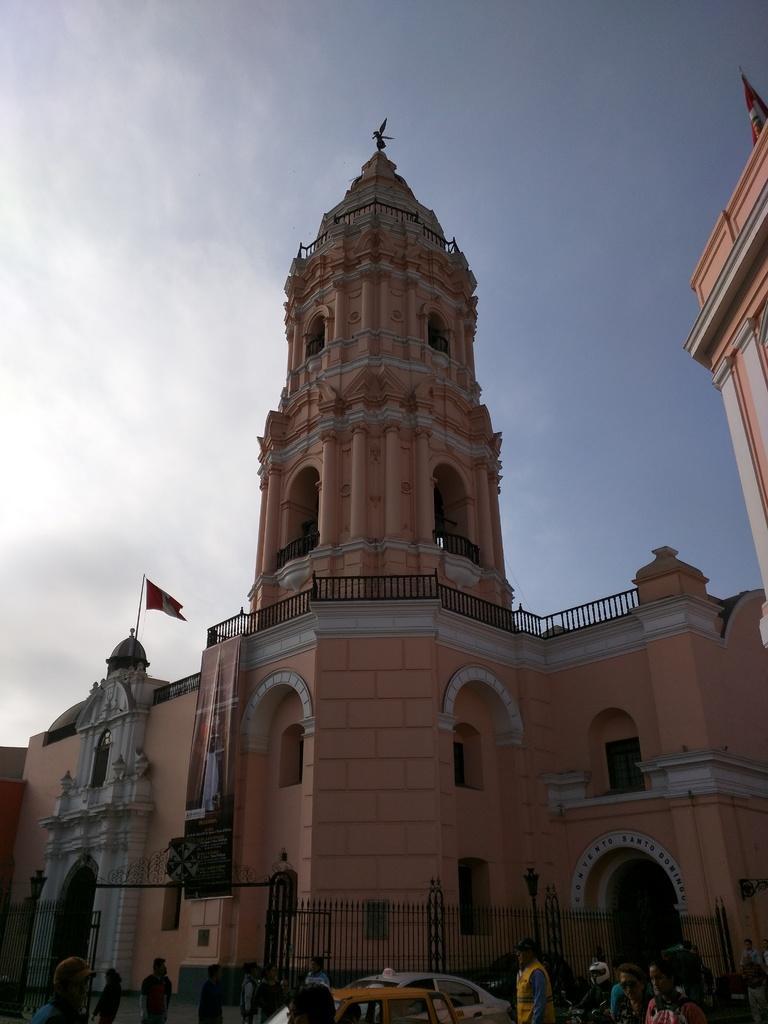How would you summarize this image in a sentence or two? In this image few persons are on the road. There are few vehicles on the road. A person is wearing a helmet. There is a fence. Behind there is a building having a flag on it. Top of the image there is sky. 